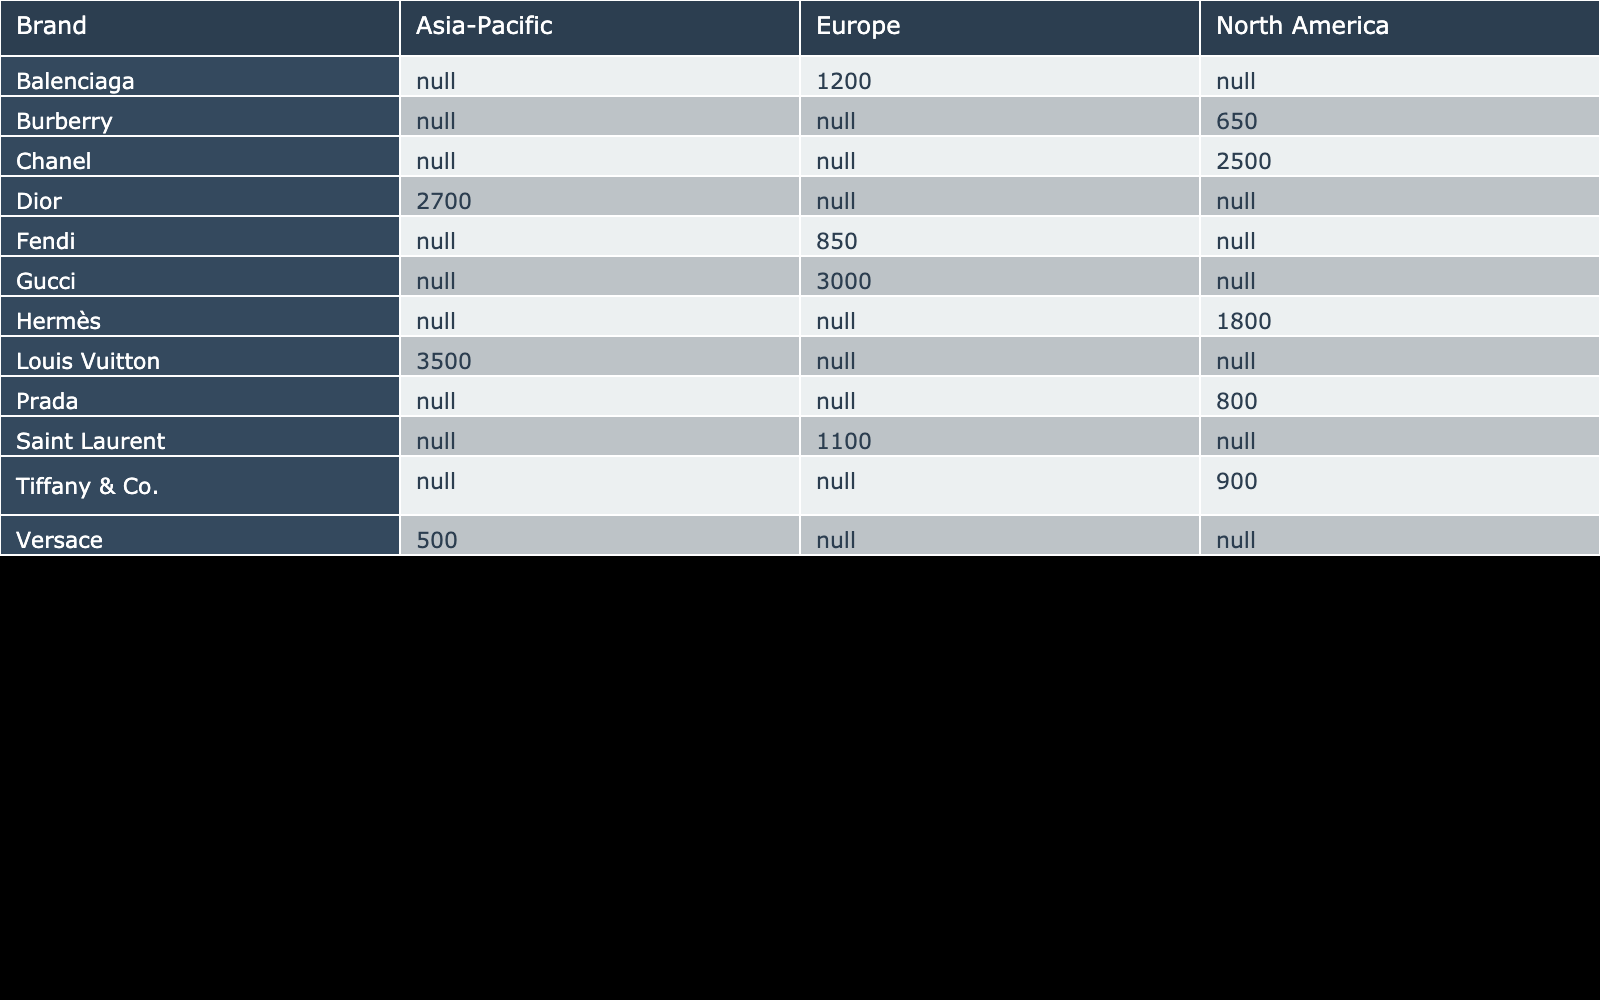What is the total sales for Chanel in North America? In the table, under the 'Chanel' row, the 'North America' column shows a sales figure of 2500 million USD.
Answer: 2500 million USD Which luxury brand had the highest sales in the Asia-Pacific region? The table indicates that Louis Vuitton, with sales of 3500 million USD, holds the highest sales figure among the luxury brands in the Asia-Pacific region.
Answer: Louis Vuitton What is the average sales amount for the luxury brands in Europe? The sales figures for Europe are 3000 (Gucci), 1200 (Balenciaga), 850 (Fendi), and 1100 (Saint Laurent), totaling 5150 million USD. There are 4 brands, so the average is 5150/4 = 1287.5 million USD.
Answer: 1287.5 million USD Did Hermès achieve a growth rate higher than 15% in North America? Hermès has a growth rate of 20% as seen in the North America column in the table, which is indeed higher than 15%.
Answer: Yes How much more in sales did Dior have compared to Versace in the Asia-Pacific region? The sales for Dior are 2700 million USD, while Versace has 500 million USD. The difference is 2700 - 500 = 2200 million USD.
Answer: 2200 million USD Which region has the lowest market share for Burberry? The table indicates that Burberry has a market share of 3% in North America, which is the lowest among all brands in the table.
Answer: North America What is the combined sales figure of Prada, Burberry, and Tiffany & Co. in North America? The sales figures for North America are 800 million USD (Prada), 650 million USD (Burberry), and 900 million USD (Tiffany & Co.). Adding them gives 800 + 650 + 900 = 2350 million USD.
Answer: 2350 million USD Is the growth rate for Fendi higher than that for Balenciaga? Fendi has a growth rate of 4%, while Balenciaga shows a higher growth rate of 18%. Thus, Fendi does not exceed Balenciaga's growth rate.
Answer: No Which brand has the second largest market share in the North American region? In North America, the brands and their market shares are: Chanel (20%), Hermès (15%), Prada (5%), Versace (3%), and Burberry (3%). The second largest market share is Hermès at 15%.
Answer: Hermès 